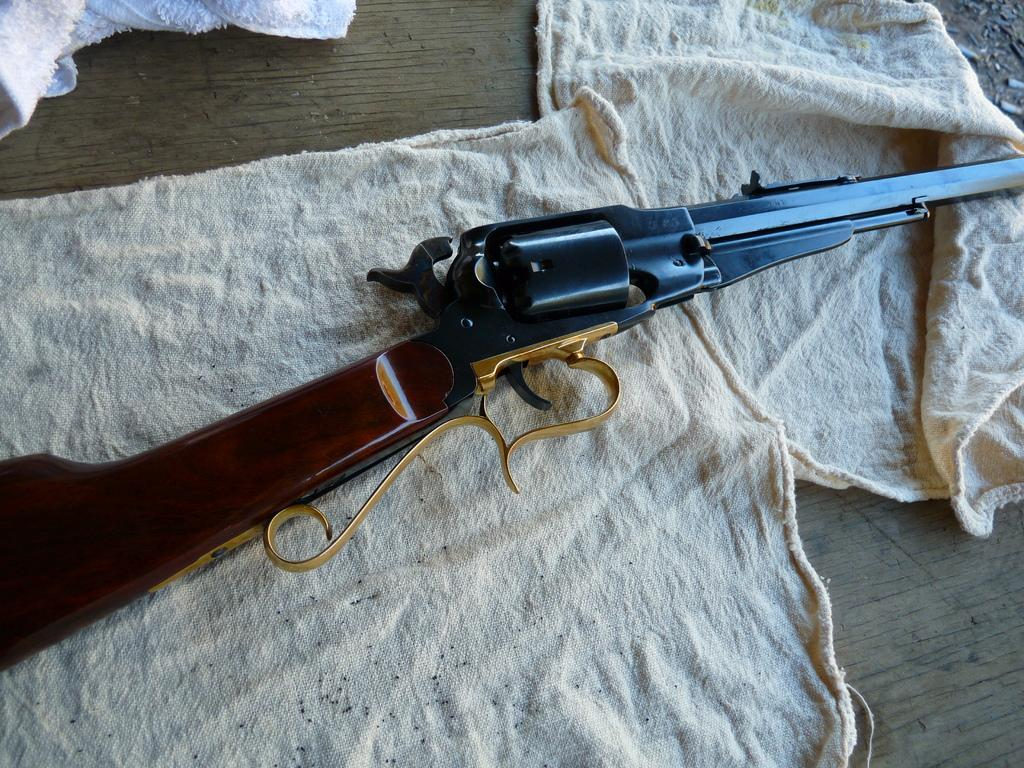What object in the image is typically used as a weapon? There is a gun in the image. What else can be seen in the image besides the gun? There are clothes in the image. What type of surface is visible in the image? The wooden surface is present in the image. What type of religion is being practiced in the image? There is no indication of any religious practice in the image; it only features a gun, clothes, and a wooden surface. 